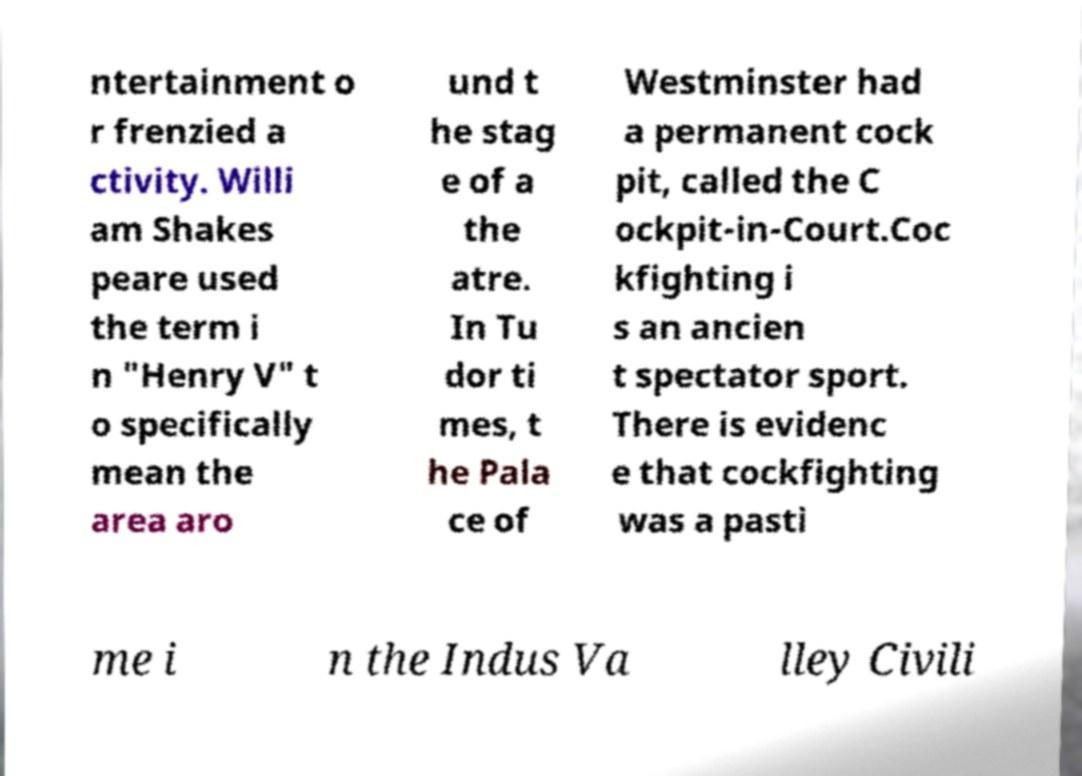Can you read and provide the text displayed in the image?This photo seems to have some interesting text. Can you extract and type it out for me? ntertainment o r frenzied a ctivity. Willi am Shakes peare used the term i n "Henry V" t o specifically mean the area aro und t he stag e of a the atre. In Tu dor ti mes, t he Pala ce of Westminster had a permanent cock pit, called the C ockpit-in-Court.Coc kfighting i s an ancien t spectator sport. There is evidenc e that cockfighting was a pasti me i n the Indus Va lley Civili 